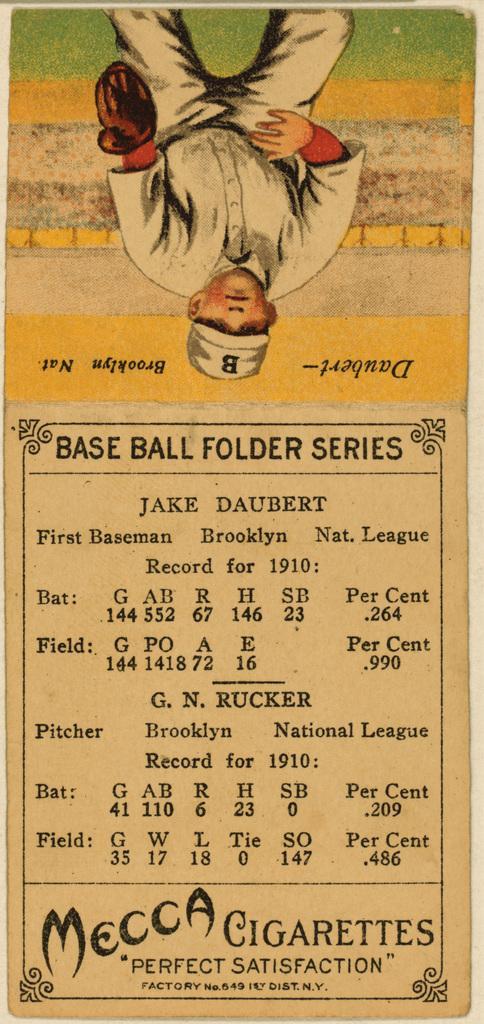Describe this image in one or two sentences. This is a paper. At the top of the image we can see the ground, wall and a man is standing and wearing cap, glove. In the background of the image we can see the text. 